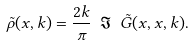Convert formula to latex. <formula><loc_0><loc_0><loc_500><loc_500>\tilde { \rho } ( x , k ) = \frac { 2 k } { \pi } \ \Im \ \tilde { G } ( x , x , k ) .</formula> 